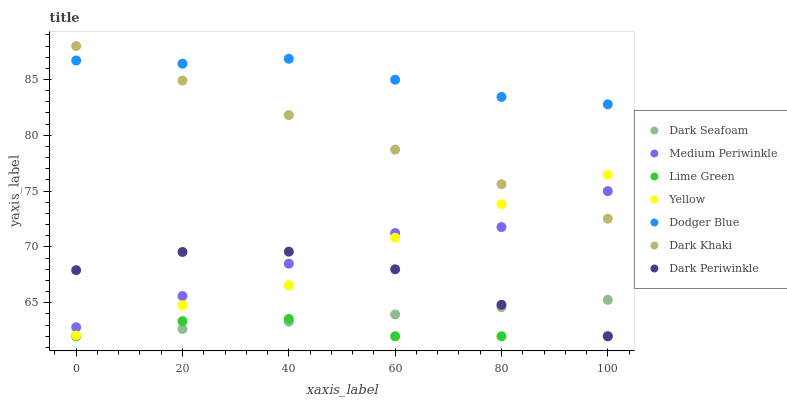Does Lime Green have the minimum area under the curve?
Answer yes or no. Yes. Does Dodger Blue have the maximum area under the curve?
Answer yes or no. Yes. Does Yellow have the minimum area under the curve?
Answer yes or no. No. Does Yellow have the maximum area under the curve?
Answer yes or no. No. Is Dark Khaki the smoothest?
Answer yes or no. Yes. Is Dark Periwinkle the roughest?
Answer yes or no. Yes. Is Yellow the smoothest?
Answer yes or no. No. Is Yellow the roughest?
Answer yes or no. No. Does Dark Seafoam have the lowest value?
Answer yes or no. Yes. Does Yellow have the lowest value?
Answer yes or no. No. Does Dark Khaki have the highest value?
Answer yes or no. Yes. Does Yellow have the highest value?
Answer yes or no. No. Is Dark Seafoam less than Dodger Blue?
Answer yes or no. Yes. Is Medium Periwinkle greater than Dark Seafoam?
Answer yes or no. Yes. Does Dark Periwinkle intersect Lime Green?
Answer yes or no. Yes. Is Dark Periwinkle less than Lime Green?
Answer yes or no. No. Is Dark Periwinkle greater than Lime Green?
Answer yes or no. No. Does Dark Seafoam intersect Dodger Blue?
Answer yes or no. No. 